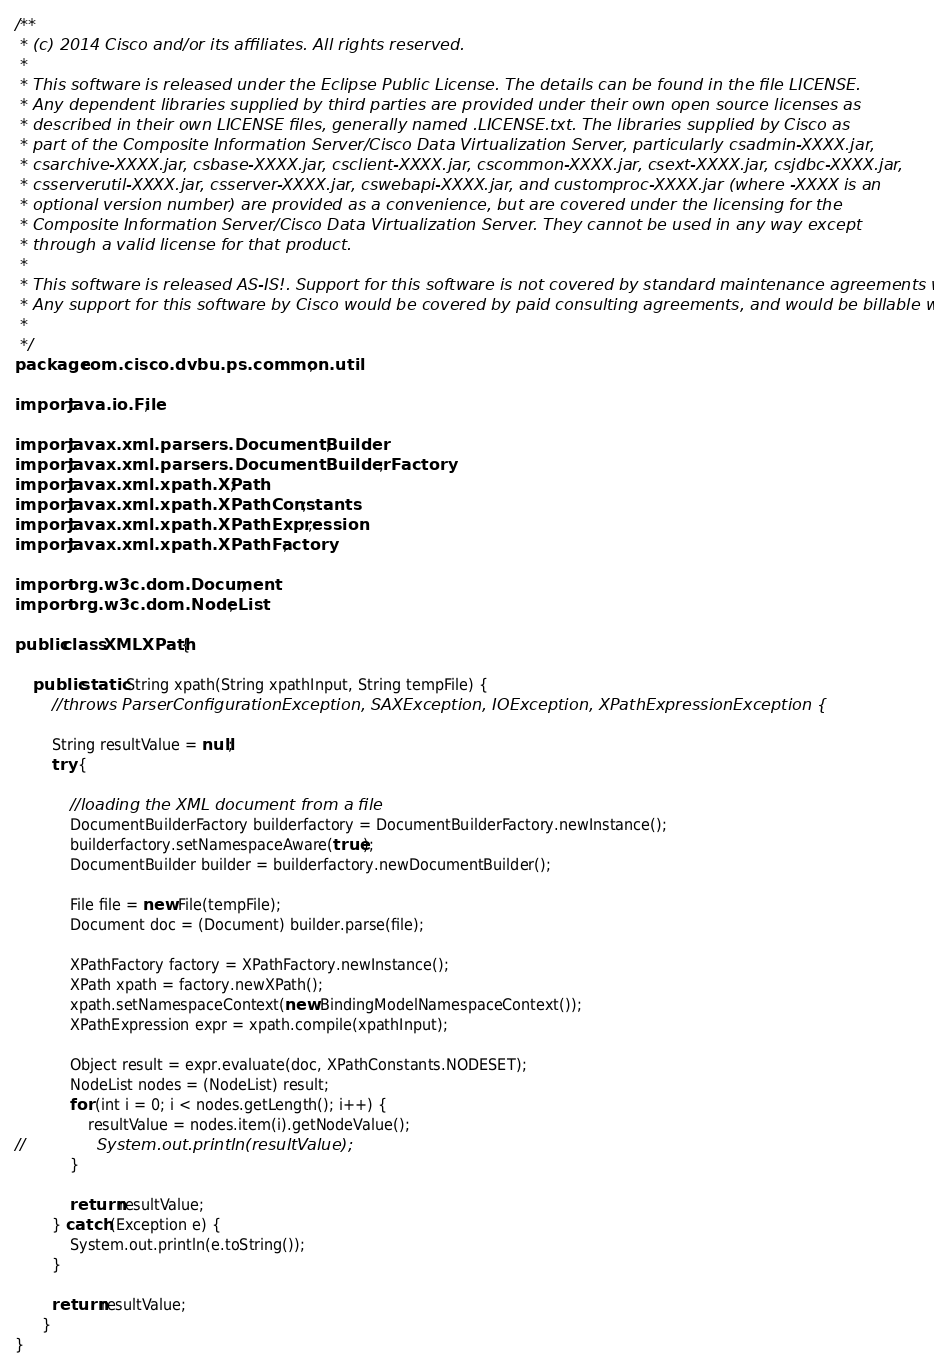Convert code to text. <code><loc_0><loc_0><loc_500><loc_500><_Java_>/**
 * (c) 2014 Cisco and/or its affiliates. All rights reserved.
 * 
 * This software is released under the Eclipse Public License. The details can be found in the file LICENSE. 
 * Any dependent libraries supplied by third parties are provided under their own open source licenses as 
 * described in their own LICENSE files, generally named .LICENSE.txt. The libraries supplied by Cisco as 
 * part of the Composite Information Server/Cisco Data Virtualization Server, particularly csadmin-XXXX.jar, 
 * csarchive-XXXX.jar, csbase-XXXX.jar, csclient-XXXX.jar, cscommon-XXXX.jar, csext-XXXX.jar, csjdbc-XXXX.jar, 
 * csserverutil-XXXX.jar, csserver-XXXX.jar, cswebapi-XXXX.jar, and customproc-XXXX.jar (where -XXXX is an 
 * optional version number) are provided as a convenience, but are covered under the licensing for the 
 * Composite Information Server/Cisco Data Virtualization Server. They cannot be used in any way except 
 * through a valid license for that product.
 * 
 * This software is released AS-IS!. Support for this software is not covered by standard maintenance agreements with Cisco. 
 * Any support for this software by Cisco would be covered by paid consulting agreements, and would be billable work.
 * 
 */
package com.cisco.dvbu.ps.common.util;

import java.io.File;

import javax.xml.parsers.DocumentBuilder;
import javax.xml.parsers.DocumentBuilderFactory;
import javax.xml.xpath.XPath;
import javax.xml.xpath.XPathConstants;
import javax.xml.xpath.XPathExpression;
import javax.xml.xpath.XPathFactory;

import org.w3c.dom.Document;
import org.w3c.dom.NodeList;

public class XMLXPath {

	public static String xpath(String xpathInput, String tempFile) {
		//throws ParserConfigurationException, SAXException, IOException, XPathExpressionException {
	
		String resultValue = null;
	    try {

			//loading the XML document from a file
			DocumentBuilderFactory builderfactory = DocumentBuilderFactory.newInstance();
			builderfactory.setNamespaceAware(true);
			DocumentBuilder builder = builderfactory.newDocumentBuilder();
				
	    	File file = new File(tempFile);
	    	Document doc = (Document) builder.parse(file);

		    XPathFactory factory = XPathFactory.newInstance();
		    XPath xpath = factory.newXPath();
		    xpath.setNamespaceContext(new BindingModelNamespaceContext());
		    XPathExpression expr = xpath.compile(xpathInput);

		    Object result = expr.evaluate(doc, XPathConstants.NODESET);
		    NodeList nodes = (NodeList) result;
		    for (int i = 0; i < nodes.getLength(); i++) {
		    	resultValue = nodes.item(i).getNodeValue();
//		        System.out.println(resultValue); 
		    }

		    return resultValue;
	    } catch (Exception e) {
	    	System.out.println(e.toString());
	    }

	    return resultValue;
	  }
}
</code> 